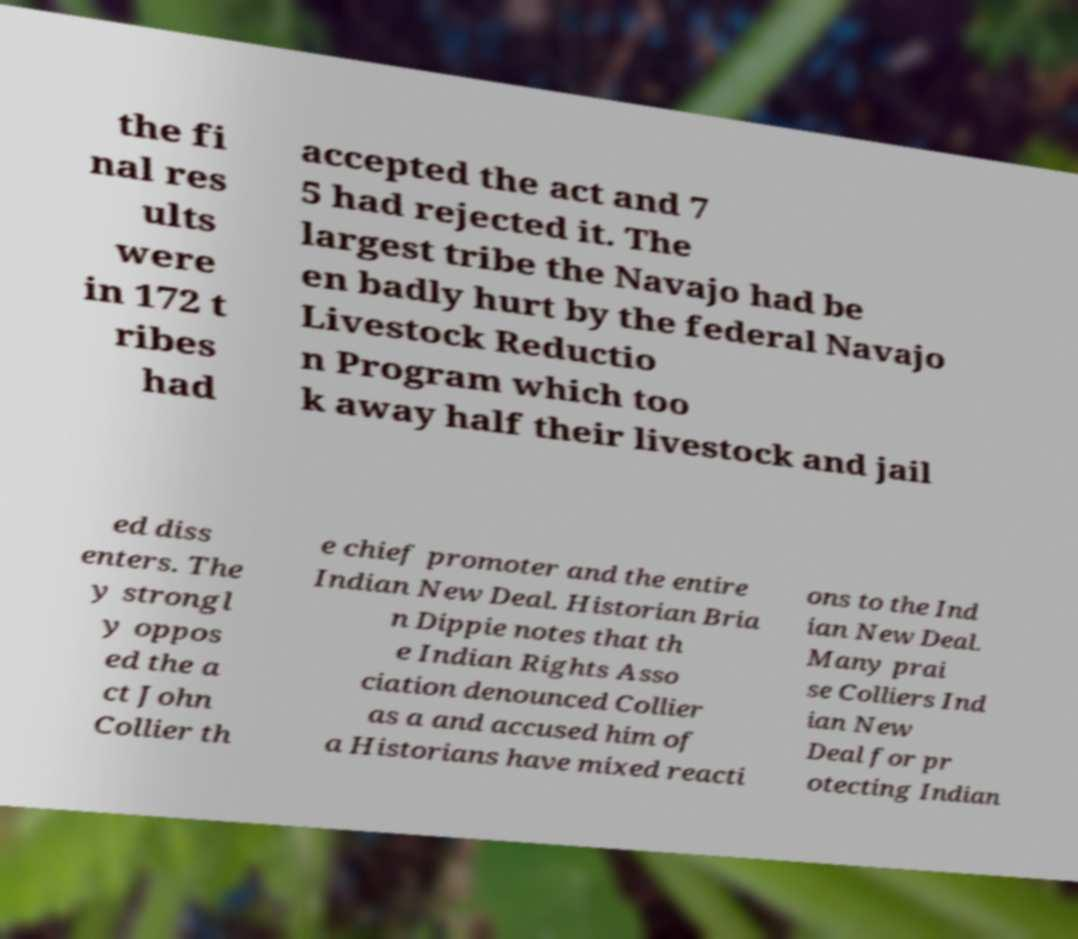Please identify and transcribe the text found in this image. the fi nal res ults were in 172 t ribes had accepted the act and 7 5 had rejected it. The largest tribe the Navajo had be en badly hurt by the federal Navajo Livestock Reductio n Program which too k away half their livestock and jail ed diss enters. The y strongl y oppos ed the a ct John Collier th e chief promoter and the entire Indian New Deal. Historian Bria n Dippie notes that th e Indian Rights Asso ciation denounced Collier as a and accused him of a Historians have mixed reacti ons to the Ind ian New Deal. Many prai se Colliers Ind ian New Deal for pr otecting Indian 